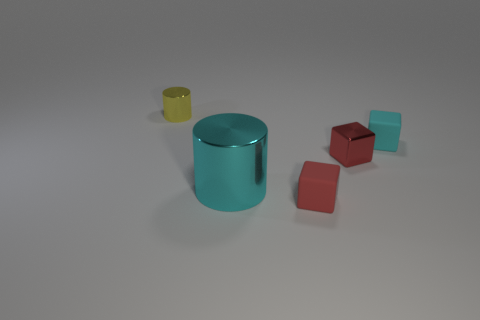There is a small matte thing that is the same color as the shiny cube; what is its shape?
Your answer should be compact. Cube. Is there a blue rubber block that has the same size as the metal block?
Your answer should be compact. No. Is the number of big cyan shiny cylinders to the right of the cyan cube greater than the number of small things in front of the large cyan object?
Offer a terse response. No. Does the small yellow cylinder have the same material as the red cube in front of the cyan metallic thing?
Provide a short and direct response. No. There is a cyan object to the right of the red shiny thing that is behind the red matte thing; what number of small metallic blocks are in front of it?
Give a very brief answer. 1. Do the tiny cyan matte thing and the yellow metallic thing behind the big cylinder have the same shape?
Make the answer very short. No. What is the color of the thing that is in front of the small metal block and on the left side of the tiny red matte cube?
Keep it short and to the point. Cyan. The cyan thing behind the metal cylinder right of the metal thing that is on the left side of the big cyan thing is made of what material?
Give a very brief answer. Rubber. What is the material of the small cyan object?
Provide a short and direct response. Rubber. There is a metal object that is the same shape as the tiny red rubber thing; what size is it?
Provide a succinct answer. Small. 